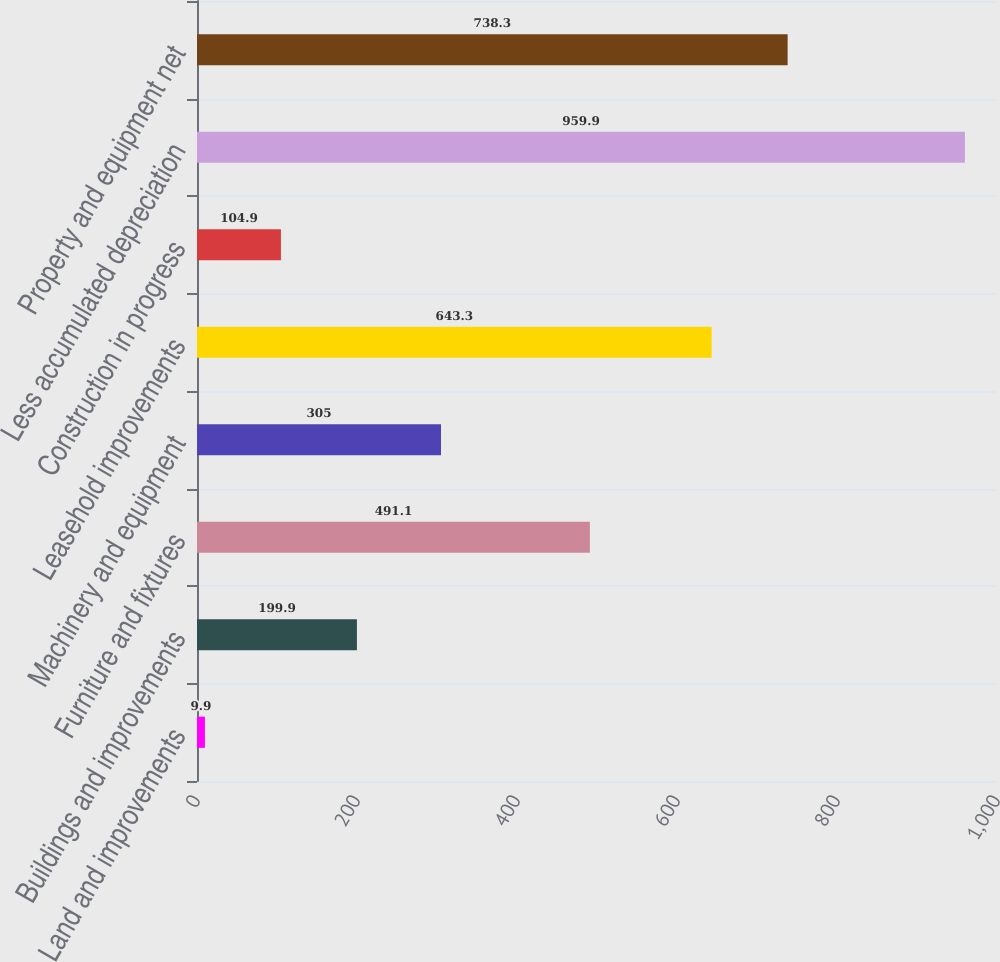Convert chart. <chart><loc_0><loc_0><loc_500><loc_500><bar_chart><fcel>Land and improvements<fcel>Buildings and improvements<fcel>Furniture and fixtures<fcel>Machinery and equipment<fcel>Leasehold improvements<fcel>Construction in progress<fcel>Less accumulated depreciation<fcel>Property and equipment net<nl><fcel>9.9<fcel>199.9<fcel>491.1<fcel>305<fcel>643.3<fcel>104.9<fcel>959.9<fcel>738.3<nl></chart> 